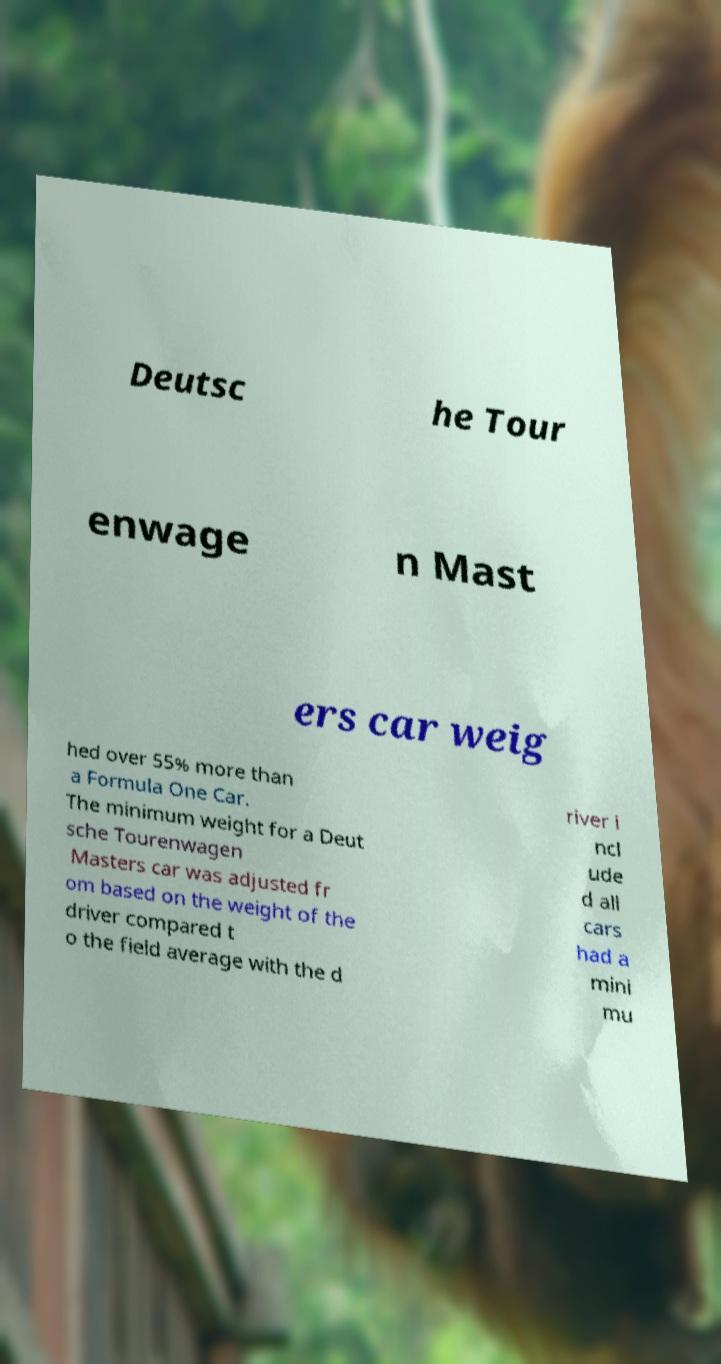What messages or text are displayed in this image? I need them in a readable, typed format. Deutsc he Tour enwage n Mast ers car weig hed over 55% more than a Formula One Car. The minimum weight for a Deut sche Tourenwagen Masters car was adjusted fr om based on the weight of the driver compared t o the field average with the d river i ncl ude d all cars had a mini mu 